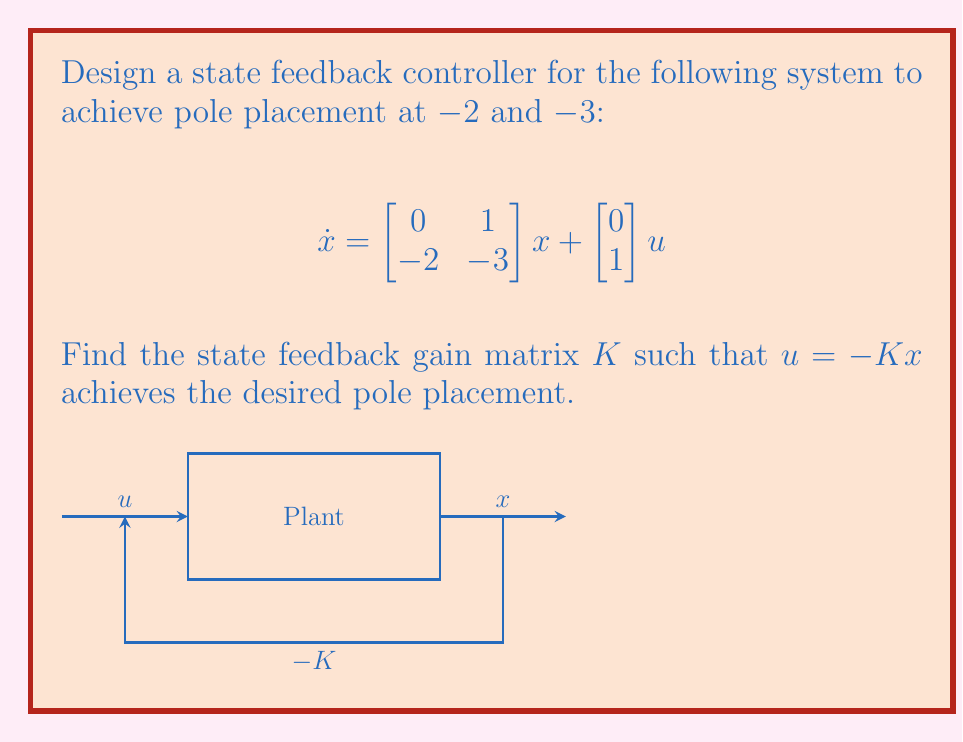Can you solve this math problem? 1) The characteristic equation of the closed-loop system is:
   $$det(sI - (A-BK)) = 0$$
   where $A = \begin{bmatrix} 0 & 1 \\ -2 & -3 \end{bmatrix}$ and $B = \begin{bmatrix} 0 \\ 1 \end{bmatrix}$

2) Let $K = [k_1 \quad k_2]$. Then:
   $$A-BK = \begin{bmatrix} 0 & 1 \\ -2-k_1 & -3-k_2 \end{bmatrix}$$

3) The characteristic equation becomes:
   $$s^2 + (3+k_2)s + (2+k_1) = 0$$

4) The desired characteristic equation is:
   $$(s+2)(s+3) = s^2 + 5s + 6 = 0$$

5) Comparing coefficients:
   $3+k_2 = 5$
   $2+k_1 = 6$

6) Solving these equations:
   $k_2 = 2$
   $k_1 = 4$

Therefore, $K = [4 \quad 2]$.
Answer: $K = [4 \quad 2]$ 